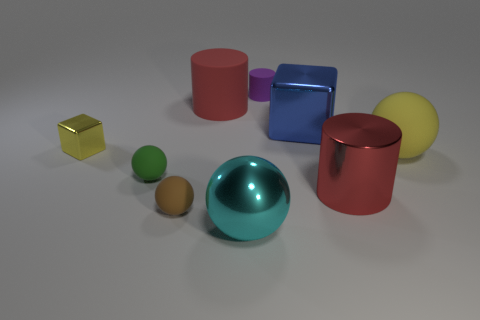Is there a large purple shiny thing?
Your answer should be very brief. No. There is a big cylinder that is the same material as the big yellow object; what is its color?
Your response must be concise. Red. What color is the large sphere to the left of the yellow object to the right of the blue shiny object that is in front of the small purple thing?
Offer a terse response. Cyan. Is the size of the cyan ball the same as the yellow object that is to the left of the red metallic object?
Offer a very short reply. No. How many things are small yellow shiny objects behind the cyan metal object or tiny rubber things that are in front of the green matte thing?
Ensure brevity in your answer.  2. The cyan metal thing that is the same size as the shiny cylinder is what shape?
Offer a very short reply. Sphere. What is the shape of the large matte object that is on the right side of the tiny thing on the right side of the big red cylinder behind the tiny block?
Ensure brevity in your answer.  Sphere. Is the number of tiny brown things that are on the left side of the brown rubber object the same as the number of green matte balls?
Your response must be concise. No. Does the yellow metallic block have the same size as the purple matte cylinder?
Your answer should be compact. Yes. What number of matte things are either small red blocks or big red things?
Provide a succinct answer. 1. 